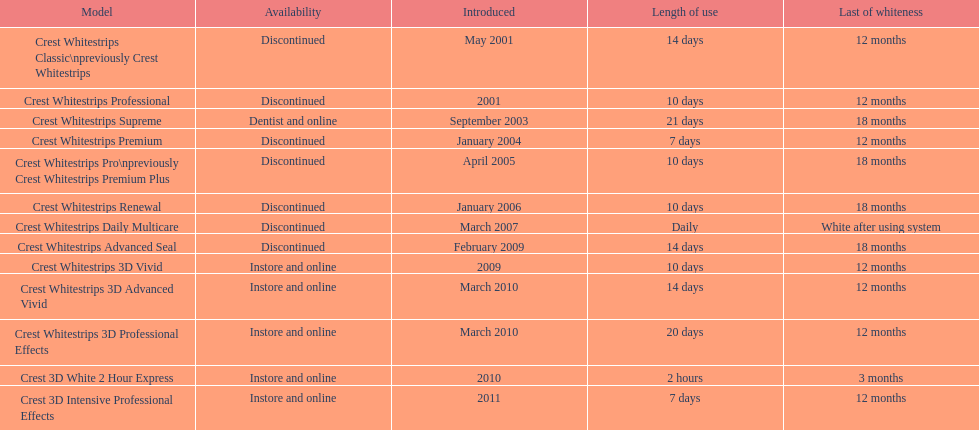Is each white strip discontinued? No. 